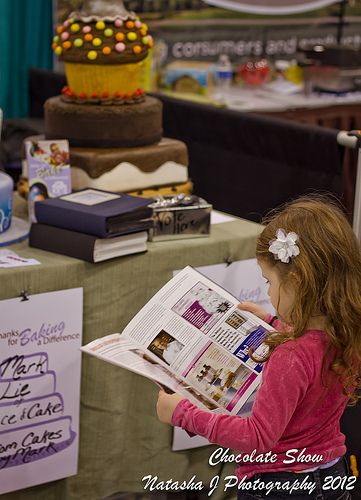Is the dessert on the table has what size? The dessert on the table, which appears to be a large tiered cake, is considerably larger than typical bakery items like cupcakes also present on the table. 